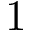<formula> <loc_0><loc_0><loc_500><loc_500>1</formula> 